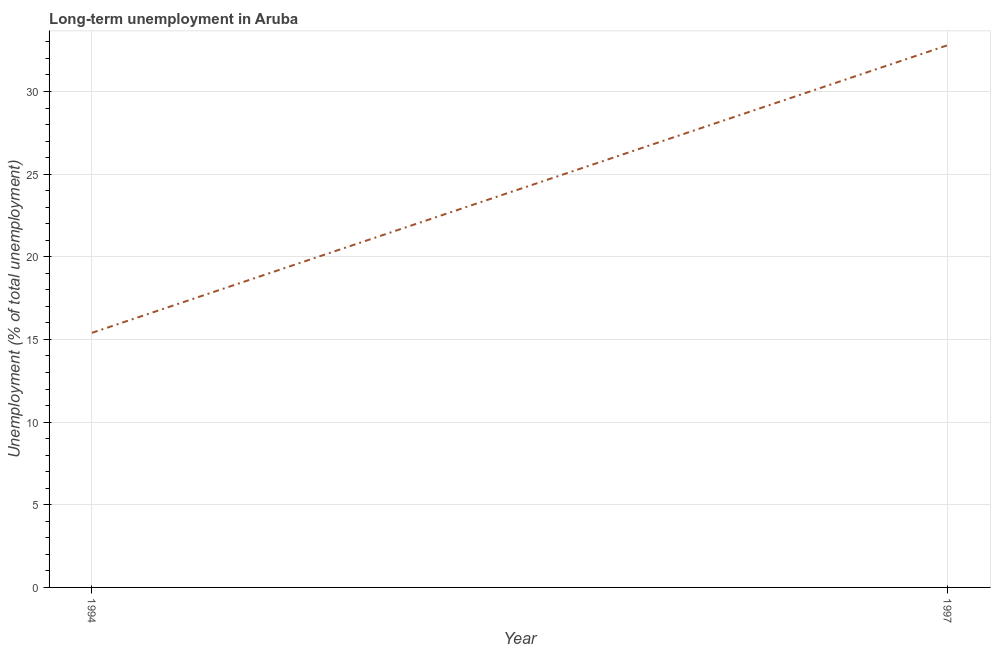What is the long-term unemployment in 1997?
Ensure brevity in your answer.  32.8. Across all years, what is the maximum long-term unemployment?
Your answer should be very brief. 32.8. Across all years, what is the minimum long-term unemployment?
Ensure brevity in your answer.  15.4. In which year was the long-term unemployment maximum?
Provide a succinct answer. 1997. In which year was the long-term unemployment minimum?
Give a very brief answer. 1994. What is the sum of the long-term unemployment?
Offer a very short reply. 48.2. What is the difference between the long-term unemployment in 1994 and 1997?
Make the answer very short. -17.4. What is the average long-term unemployment per year?
Give a very brief answer. 24.1. What is the median long-term unemployment?
Ensure brevity in your answer.  24.1. Do a majority of the years between 1994 and 1997 (inclusive) have long-term unemployment greater than 29 %?
Ensure brevity in your answer.  No. What is the ratio of the long-term unemployment in 1994 to that in 1997?
Give a very brief answer. 0.47. Is the long-term unemployment in 1994 less than that in 1997?
Your answer should be very brief. Yes. Does the long-term unemployment monotonically increase over the years?
Offer a terse response. Yes. How many years are there in the graph?
Keep it short and to the point. 2. Are the values on the major ticks of Y-axis written in scientific E-notation?
Your answer should be very brief. No. Does the graph contain any zero values?
Make the answer very short. No. What is the title of the graph?
Offer a very short reply. Long-term unemployment in Aruba. What is the label or title of the X-axis?
Your answer should be compact. Year. What is the label or title of the Y-axis?
Your answer should be very brief. Unemployment (% of total unemployment). What is the Unemployment (% of total unemployment) in 1994?
Your answer should be compact. 15.4. What is the Unemployment (% of total unemployment) of 1997?
Make the answer very short. 32.8. What is the difference between the Unemployment (% of total unemployment) in 1994 and 1997?
Offer a very short reply. -17.4. What is the ratio of the Unemployment (% of total unemployment) in 1994 to that in 1997?
Offer a very short reply. 0.47. 